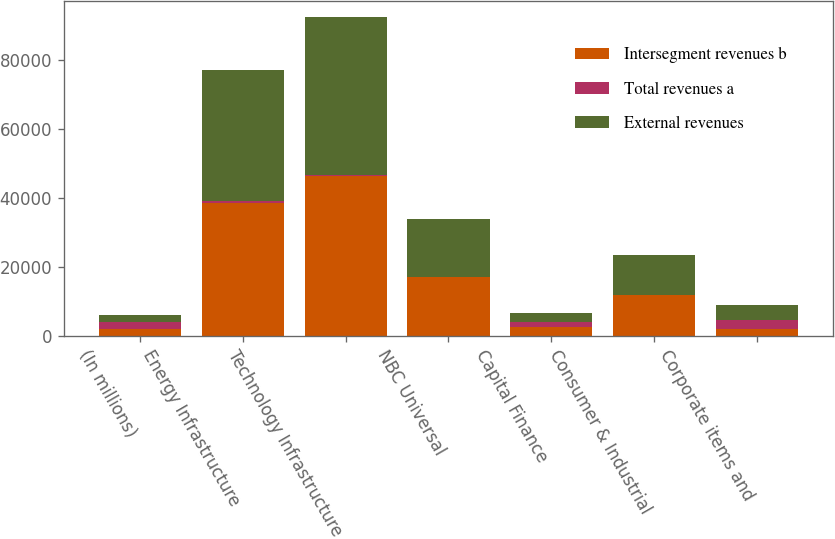Convert chart. <chart><loc_0><loc_0><loc_500><loc_500><stacked_bar_chart><ecel><fcel>(In millions)<fcel>Energy Infrastructure<fcel>Technology Infrastructure<fcel>NBC Universal<fcel>Capital Finance<fcel>Consumer & Industrial<fcel>Corporate items and<nl><fcel>Intersegment revenues b<fcel>2008<fcel>38571<fcel>46316<fcel>16969<fcel>2555<fcel>11737<fcel>1914<nl><fcel>Total revenues a<fcel>2008<fcel>664<fcel>273<fcel>89<fcel>1333<fcel>196<fcel>2555<nl><fcel>External revenues<fcel>2008<fcel>37907<fcel>46043<fcel>16880<fcel>2555<fcel>11541<fcel>4469<nl></chart> 